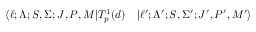<formula> <loc_0><loc_0><loc_500><loc_500>\begin{array} { r l } { \langle \ell ; \Lambda ; S , \Sigma ; J , P , M | T _ { p } ^ { 1 } ( d ) } & | \ell ^ { \prime } ; \Lambda ^ { \prime } ; S , \Sigma ^ { \prime } ; J ^ { \prime } , P ^ { \prime } , M ^ { \prime } \rangle } \end{array}</formula> 